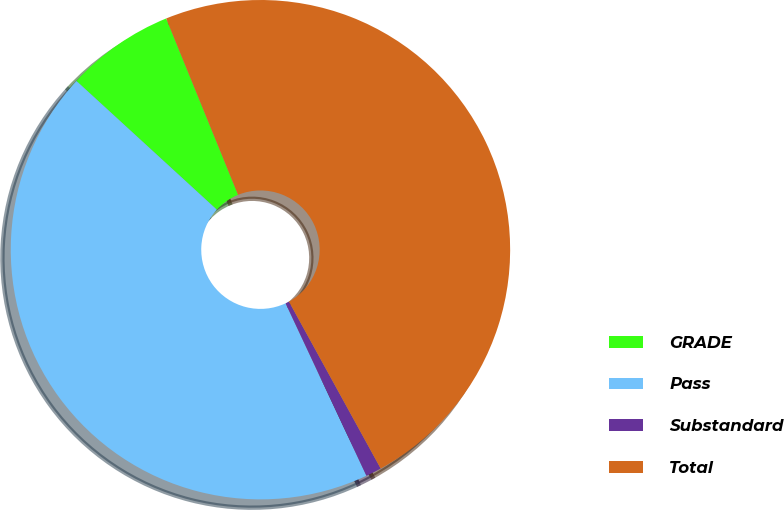<chart> <loc_0><loc_0><loc_500><loc_500><pie_chart><fcel>GRADE<fcel>Pass<fcel>Substandard<fcel>Total<nl><fcel>7.03%<fcel>43.79%<fcel>1.02%<fcel>48.17%<nl></chart> 